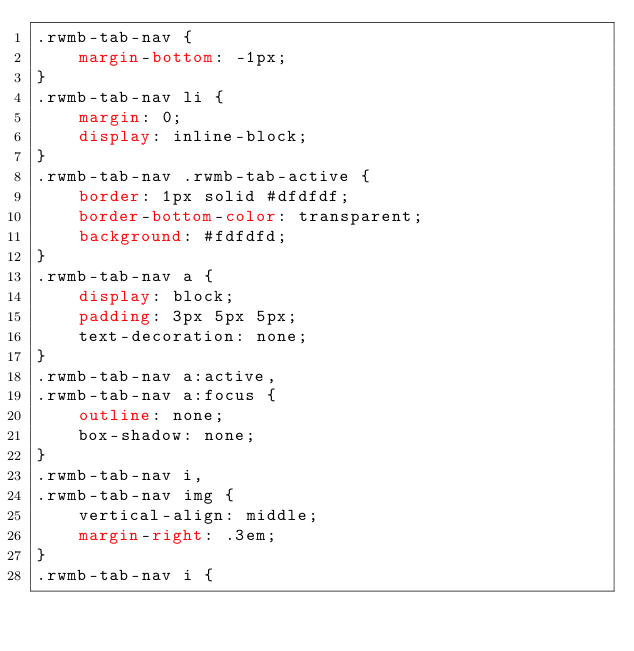Convert code to text. <code><loc_0><loc_0><loc_500><loc_500><_CSS_>.rwmb-tab-nav {
	margin-bottom: -1px;
}
.rwmb-tab-nav li {
	margin: 0;
	display: inline-block;
}
.rwmb-tab-nav .rwmb-tab-active {
	border: 1px solid #dfdfdf;
	border-bottom-color: transparent;
	background: #fdfdfd;
}
.rwmb-tab-nav a {
	display: block;
	padding: 3px 5px 5px;
	text-decoration: none;
}
.rwmb-tab-nav a:active,
.rwmb-tab-nav a:focus {
	outline: none;
	box-shadow: none;
}
.rwmb-tab-nav i,
.rwmb-tab-nav img {
	vertical-align: middle;
	margin-right: .3em;
}
.rwmb-tab-nav i {</code> 